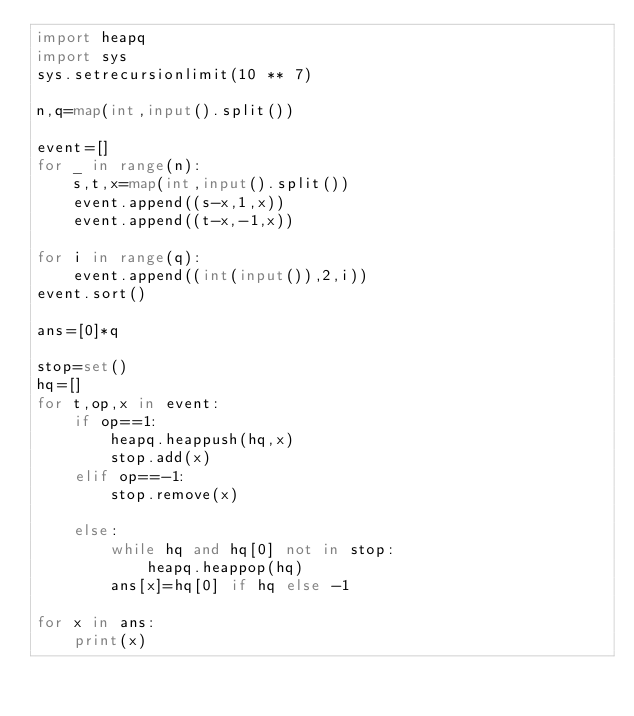Convert code to text. <code><loc_0><loc_0><loc_500><loc_500><_Python_>import heapq
import sys
sys.setrecursionlimit(10 ** 7)

n,q=map(int,input().split())

event=[]
for _ in range(n):
    s,t,x=map(int,input().split())
    event.append((s-x,1,x))
    event.append((t-x,-1,x))

for i in range(q):
    event.append((int(input()),2,i))
event.sort()

ans=[0]*q

stop=set()
hq=[]
for t,op,x in event:
    if op==1:
        heapq.heappush(hq,x)
        stop.add(x)
    elif op==-1:
        stop.remove(x)

    else:
        while hq and hq[0] not in stop:
            heapq.heappop(hq) 
        ans[x]=hq[0] if hq else -1
    
for x in ans:
    print(x)</code> 